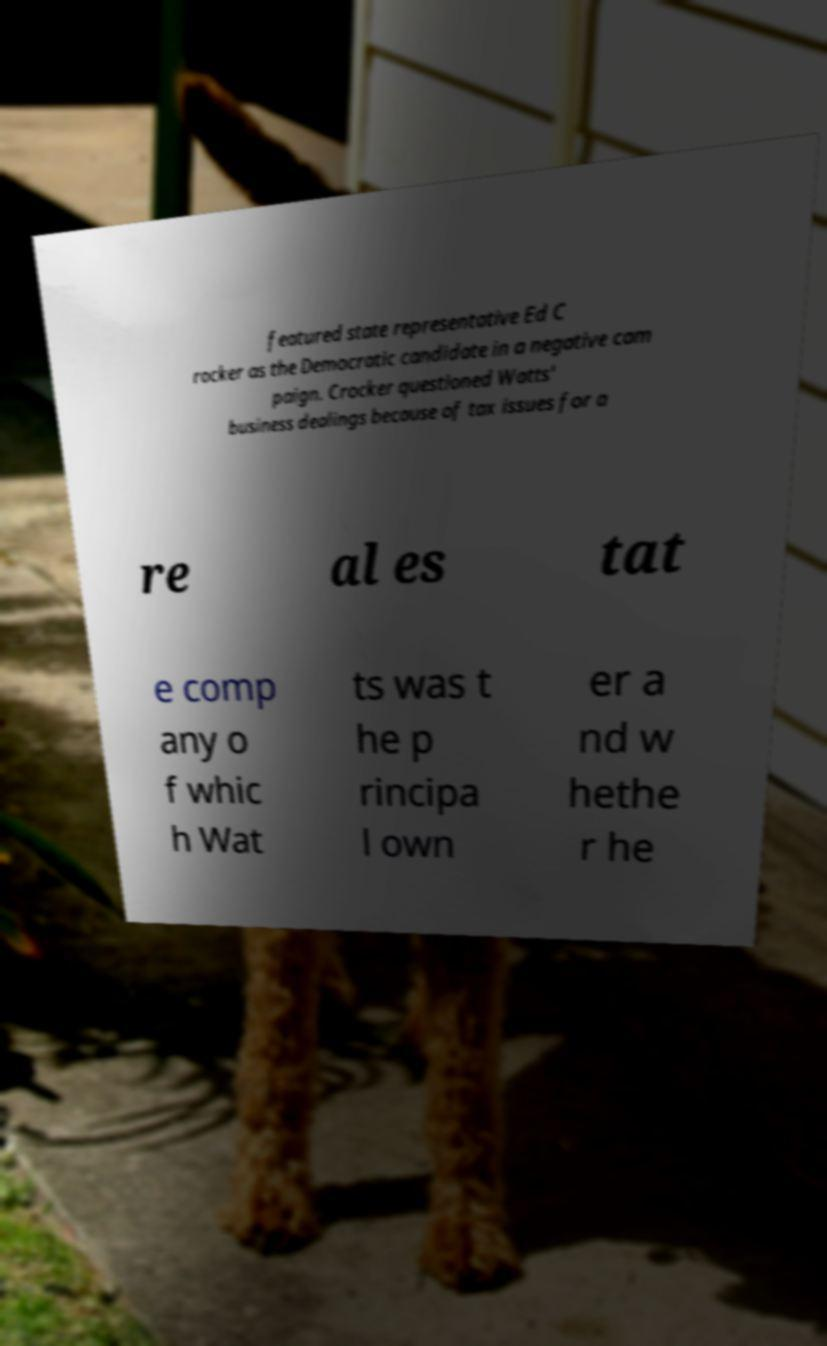Can you read and provide the text displayed in the image?This photo seems to have some interesting text. Can you extract and type it out for me? featured state representative Ed C rocker as the Democratic candidate in a negative cam paign. Crocker questioned Watts' business dealings because of tax issues for a re al es tat e comp any o f whic h Wat ts was t he p rincipa l own er a nd w hethe r he 